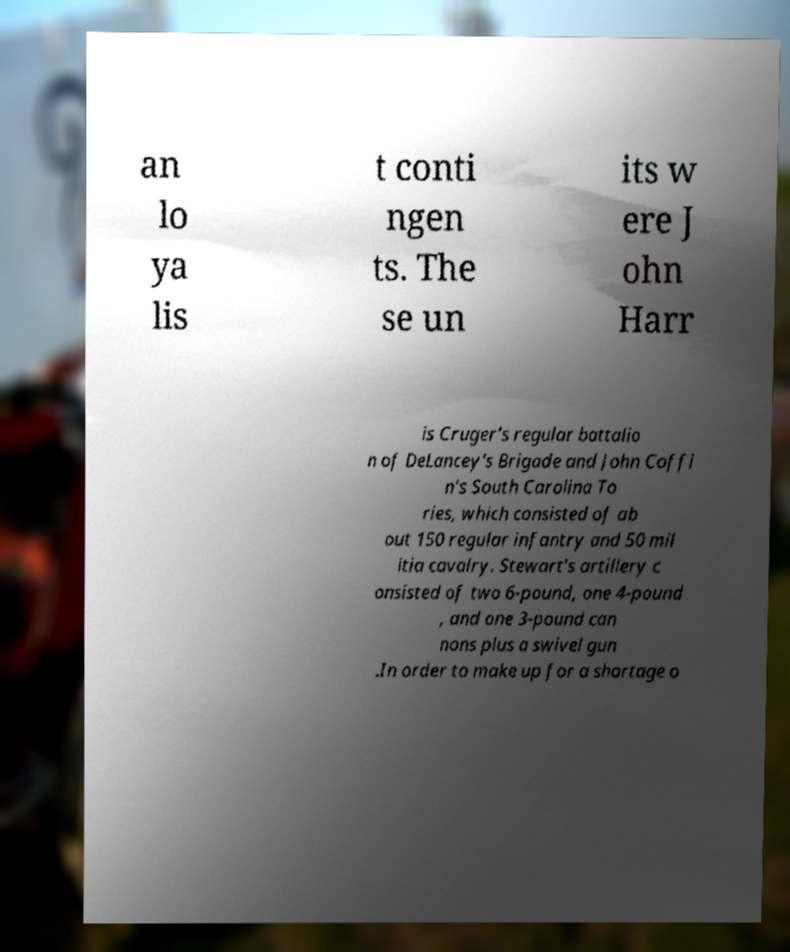Could you extract and type out the text from this image? an lo ya lis t conti ngen ts. The se un its w ere J ohn Harr is Cruger's regular battalio n of DeLancey's Brigade and John Coffi n's South Carolina To ries, which consisted of ab out 150 regular infantry and 50 mil itia cavalry. Stewart's artillery c onsisted of two 6-pound, one 4-pound , and one 3-pound can nons plus a swivel gun .In order to make up for a shortage o 